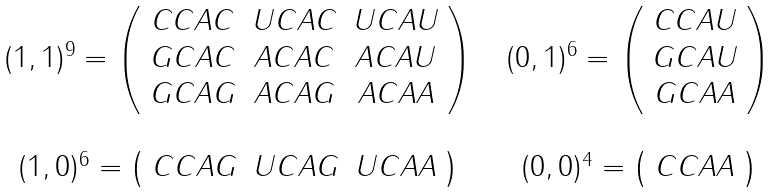Convert formula to latex. <formula><loc_0><loc_0><loc_500><loc_500>\begin{array} { c c c } ( 1 , 1 ) ^ { 9 } = \left ( \begin{array} { c c c c c } C C A C & U C A C & U C A U \\ G C A C & A C A C & A C A U \\ G C A G & A C A G & A C A A \\ \end{array} \right ) & & ( 0 , 1 ) ^ { 6 } = \left ( \begin{array} { c c c c c } C C A U \\ G C A U \\ G C A A \\ \end{array} \right ) \\ & & \\ ( 1 , 0 ) ^ { 6 } = \left ( \begin{array} { c c c c c } C C A G & U C A G & U C A A \\ \end{array} \right ) & & ( 0 , 0 ) ^ { 4 } = \left ( \begin{array} { c c c c c } C C A A \\ \end{array} \right ) \\ \end{array}</formula> 